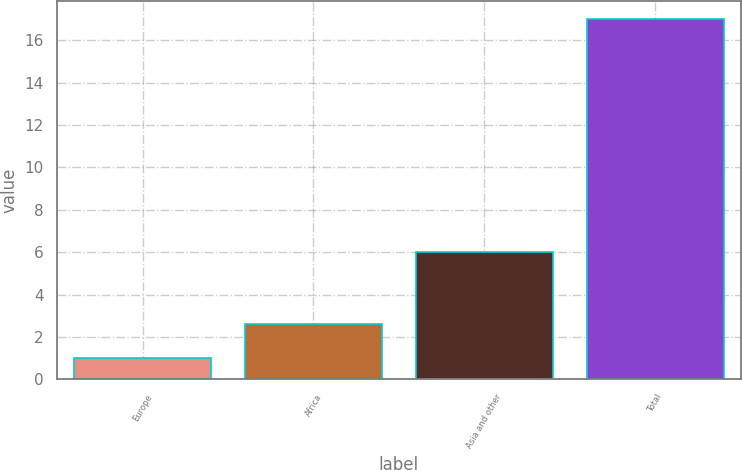<chart> <loc_0><loc_0><loc_500><loc_500><bar_chart><fcel>Europe<fcel>Africa<fcel>Asia and other<fcel>Total<nl><fcel>1<fcel>2.6<fcel>6<fcel>17<nl></chart> 